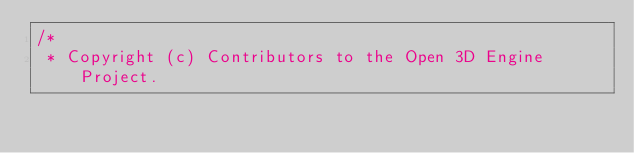Convert code to text. <code><loc_0><loc_0><loc_500><loc_500><_C++_>/*
 * Copyright (c) Contributors to the Open 3D Engine Project.</code> 